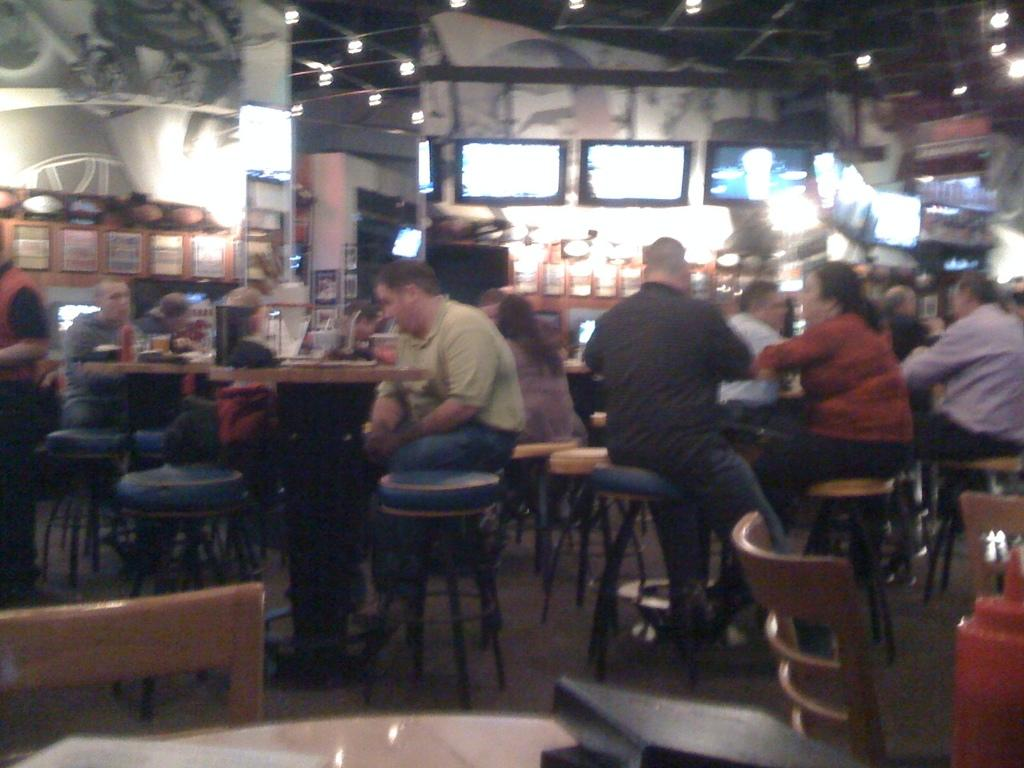What are the people in the image doing? The people in the image are sitting on chairs. What is in front of the chairs? There is a table in front of the chairs. What can be seen in the background of the image? There are TV screens visible in the background. What type of rake is being used by the person sitting on the chair? There is no rake present in the image; the people are sitting on chairs and there is a table in front of them. 